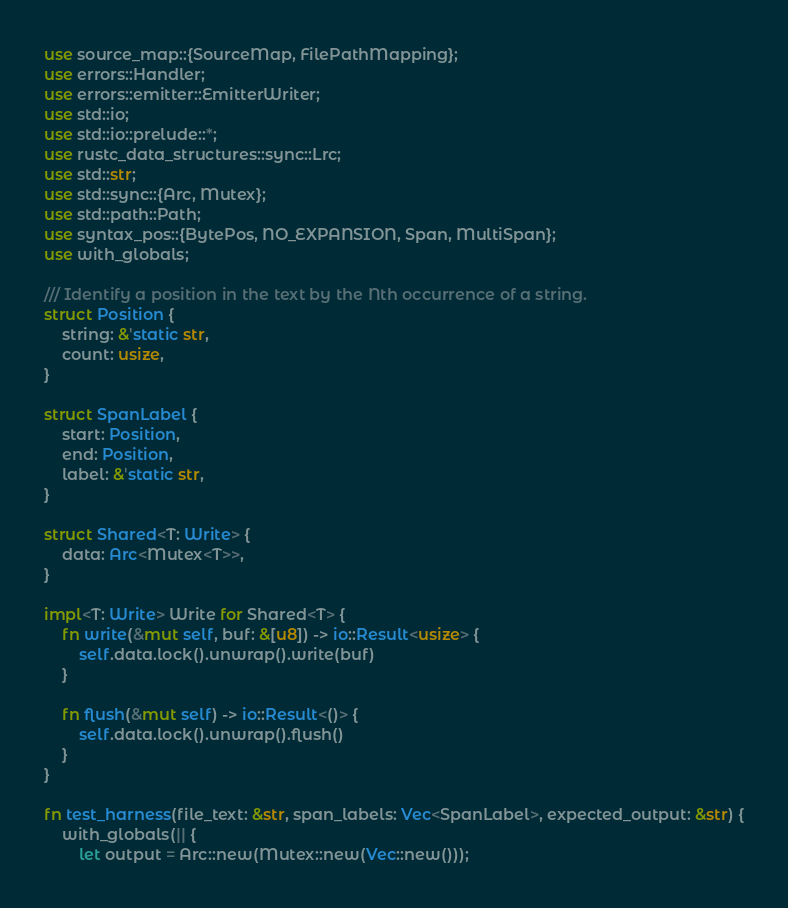Convert code to text. <code><loc_0><loc_0><loc_500><loc_500><_Rust_>use source_map::{SourceMap, FilePathMapping};
use errors::Handler;
use errors::emitter::EmitterWriter;
use std::io;
use std::io::prelude::*;
use rustc_data_structures::sync::Lrc;
use std::str;
use std::sync::{Arc, Mutex};
use std::path::Path;
use syntax_pos::{BytePos, NO_EXPANSION, Span, MultiSpan};
use with_globals;

/// Identify a position in the text by the Nth occurrence of a string.
struct Position {
    string: &'static str,
    count: usize,
}

struct SpanLabel {
    start: Position,
    end: Position,
    label: &'static str,
}

struct Shared<T: Write> {
    data: Arc<Mutex<T>>,
}

impl<T: Write> Write for Shared<T> {
    fn write(&mut self, buf: &[u8]) -> io::Result<usize> {
        self.data.lock().unwrap().write(buf)
    }

    fn flush(&mut self) -> io::Result<()> {
        self.data.lock().unwrap().flush()
    }
}

fn test_harness(file_text: &str, span_labels: Vec<SpanLabel>, expected_output: &str) {
    with_globals(|| {
        let output = Arc::new(Mutex::new(Vec::new()));
</code> 